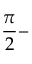<formula> <loc_0><loc_0><loc_500><loc_500>\frac { \pi } { 2 } -</formula> 